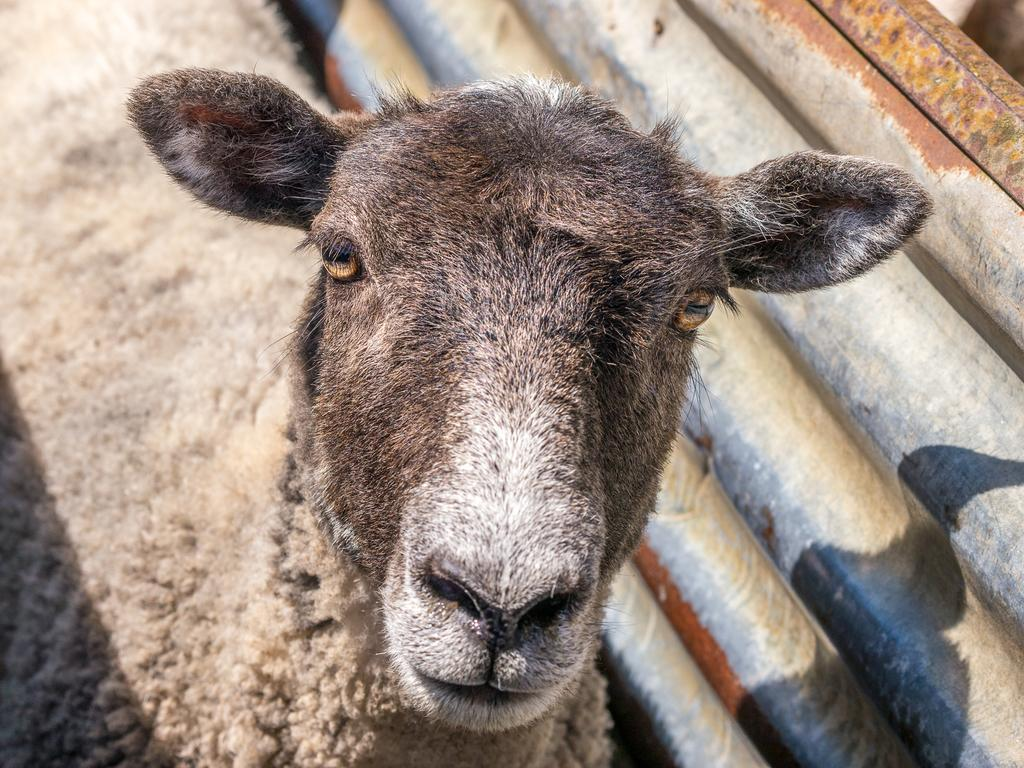What type of creature is in the image? There is an animal in the image. Can you describe the color pattern of the animal? The animal has black, white, and gray colors. What other object can be seen in the image? There is a metal sheet in the image. What type of operation is being performed on the cabbage in the image? There is no cabbage or operation present in the image. How many bikes are visible in the image? There are no bikes visible in the image. 